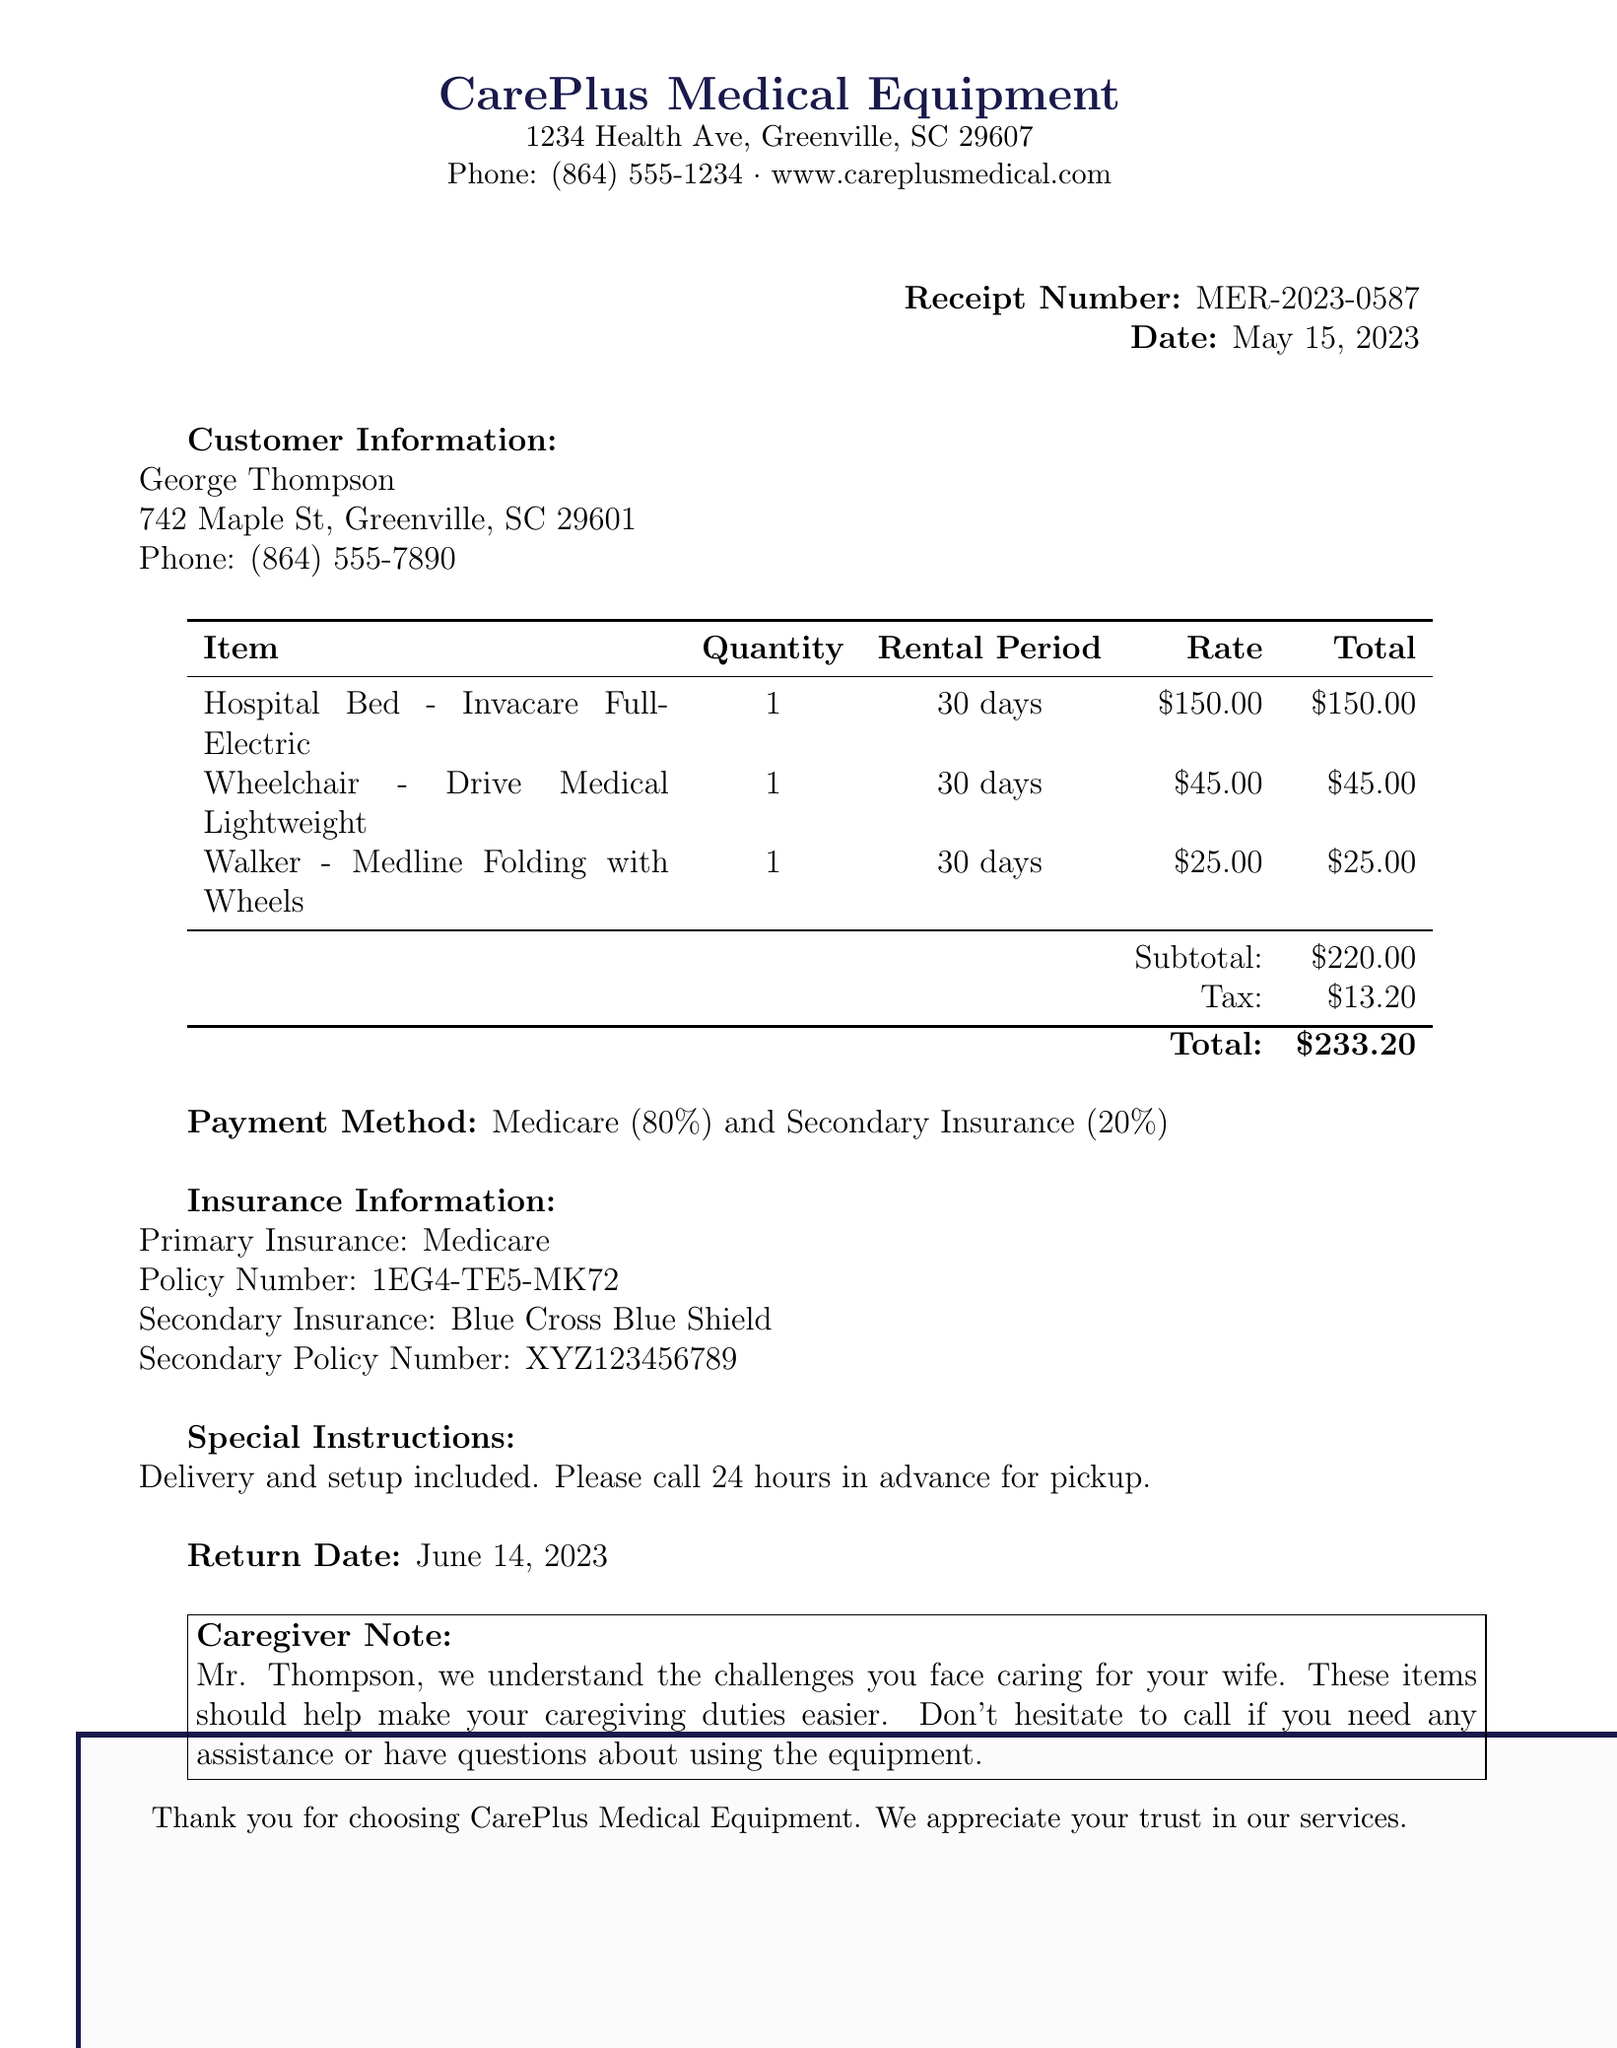What is the receipt number? The receipt number is provided at the top right of the document, identifying this particular transaction.
Answer: MER-2023-0587 What is the rental period for the hospital bed? The rental period for the hospital bed is specified in the rental items section of the document.
Answer: 30 days What is the subtotal amount? The subtotal is calculated before tax, listed clearly in the total section of the document.
Answer: $220.00 What is the phone number of the rental company? The phone number for CarePlus Medical Equipment is mentioned at the top of the document under their contact information.
Answer: (864) 555-1234 What is the return date for the rented items? The return date is explicitly stated in the document, indicating when the items should be returned.
Answer: June 14, 2023 What percentage does Medicare cover for the rental? The payment method section provides the coverage split between primary and secondary insurance.
Answer: 80% What special instructions are mentioned? Special instructions about delivery and other details are provided in the document for clarity regarding the service.
Answer: Delivery and setup included. Please call 24 hours in advance for pickup What is the total amount charged? The total amount reflects the sum of the subtotal and tax, and it's listed clearly at the end of the total section.
Answer: $233.20 